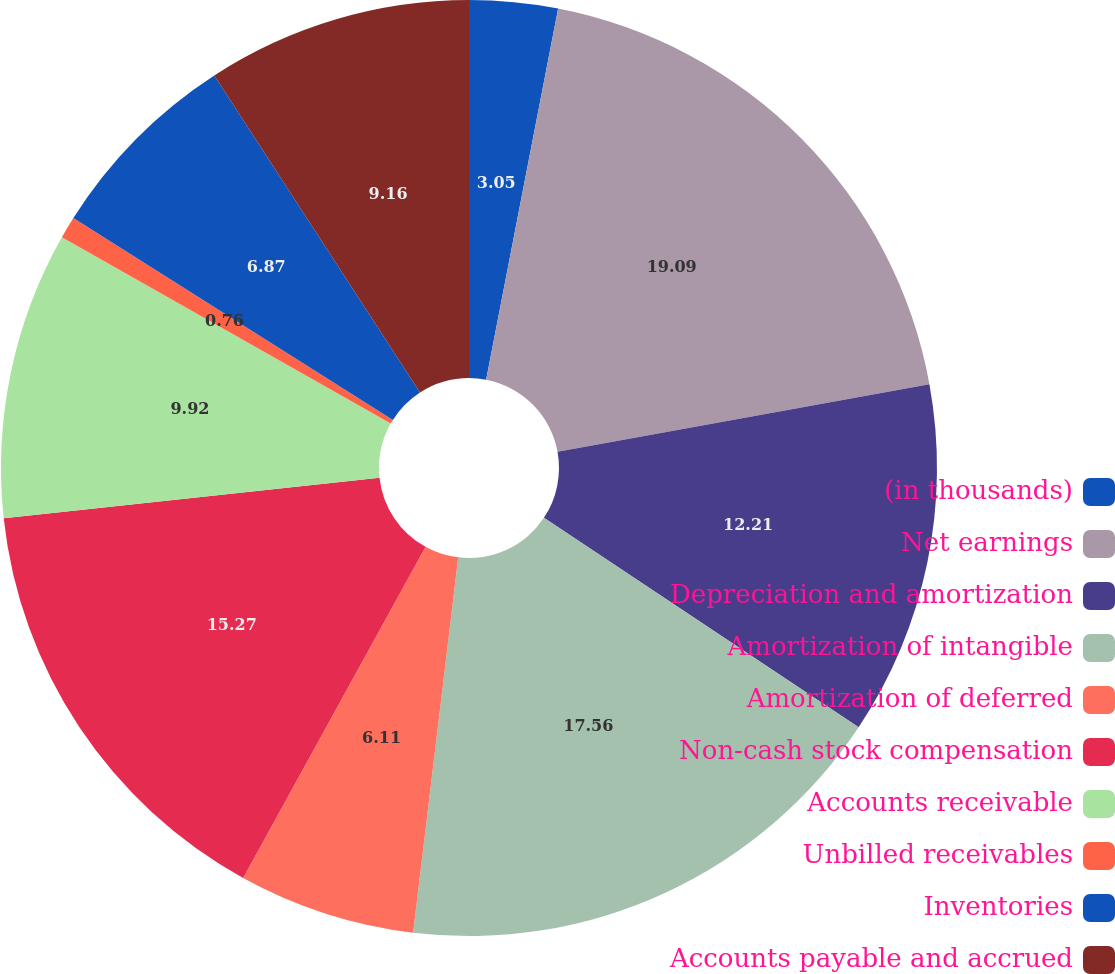<chart> <loc_0><loc_0><loc_500><loc_500><pie_chart><fcel>(in thousands)<fcel>Net earnings<fcel>Depreciation and amortization<fcel>Amortization of intangible<fcel>Amortization of deferred<fcel>Non-cash stock compensation<fcel>Accounts receivable<fcel>Unbilled receivables<fcel>Inventories<fcel>Accounts payable and accrued<nl><fcel>3.05%<fcel>19.08%<fcel>12.21%<fcel>17.56%<fcel>6.11%<fcel>15.27%<fcel>9.92%<fcel>0.76%<fcel>6.87%<fcel>9.16%<nl></chart> 